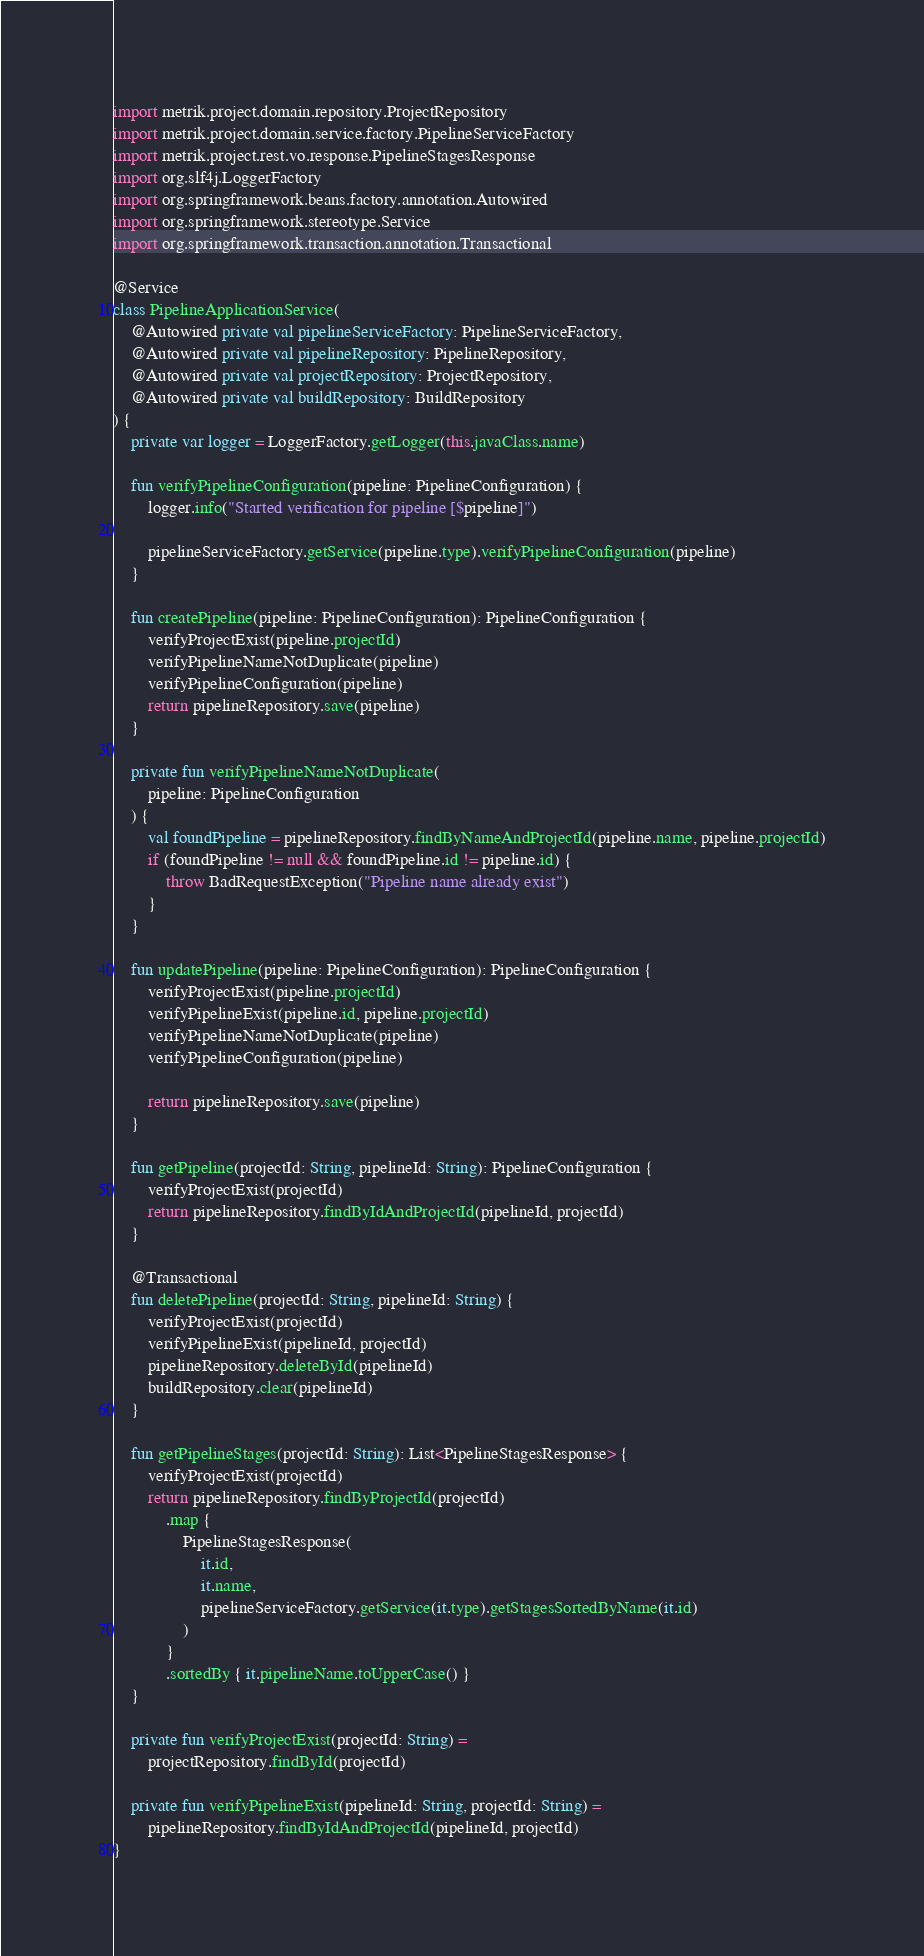Convert code to text. <code><loc_0><loc_0><loc_500><loc_500><_Kotlin_>import metrik.project.domain.repository.ProjectRepository
import metrik.project.domain.service.factory.PipelineServiceFactory
import metrik.project.rest.vo.response.PipelineStagesResponse
import org.slf4j.LoggerFactory
import org.springframework.beans.factory.annotation.Autowired
import org.springframework.stereotype.Service
import org.springframework.transaction.annotation.Transactional

@Service
class PipelineApplicationService(
    @Autowired private val pipelineServiceFactory: PipelineServiceFactory,
    @Autowired private val pipelineRepository: PipelineRepository,
    @Autowired private val projectRepository: ProjectRepository,
    @Autowired private val buildRepository: BuildRepository
) {
    private var logger = LoggerFactory.getLogger(this.javaClass.name)

    fun verifyPipelineConfiguration(pipeline: PipelineConfiguration) {
        logger.info("Started verification for pipeline [$pipeline]")

        pipelineServiceFactory.getService(pipeline.type).verifyPipelineConfiguration(pipeline)
    }

    fun createPipeline(pipeline: PipelineConfiguration): PipelineConfiguration {
        verifyProjectExist(pipeline.projectId)
        verifyPipelineNameNotDuplicate(pipeline)
        verifyPipelineConfiguration(pipeline)
        return pipelineRepository.save(pipeline)
    }

    private fun verifyPipelineNameNotDuplicate(
        pipeline: PipelineConfiguration
    ) {
        val foundPipeline = pipelineRepository.findByNameAndProjectId(pipeline.name, pipeline.projectId)
        if (foundPipeline != null && foundPipeline.id != pipeline.id) {
            throw BadRequestException("Pipeline name already exist")
        }
    }

    fun updatePipeline(pipeline: PipelineConfiguration): PipelineConfiguration {
        verifyProjectExist(pipeline.projectId)
        verifyPipelineExist(pipeline.id, pipeline.projectId)
        verifyPipelineNameNotDuplicate(pipeline)
        verifyPipelineConfiguration(pipeline)

        return pipelineRepository.save(pipeline)
    }

    fun getPipeline(projectId: String, pipelineId: String): PipelineConfiguration {
        verifyProjectExist(projectId)
        return pipelineRepository.findByIdAndProjectId(pipelineId, projectId)
    }

    @Transactional
    fun deletePipeline(projectId: String, pipelineId: String) {
        verifyProjectExist(projectId)
        verifyPipelineExist(pipelineId, projectId)
        pipelineRepository.deleteById(pipelineId)
        buildRepository.clear(pipelineId)
    }

    fun getPipelineStages(projectId: String): List<PipelineStagesResponse> {
        verifyProjectExist(projectId)
        return pipelineRepository.findByProjectId(projectId)
            .map {
                PipelineStagesResponse(
                    it.id,
                    it.name,
                    pipelineServiceFactory.getService(it.type).getStagesSortedByName(it.id)
                )
            }
            .sortedBy { it.pipelineName.toUpperCase() }
    }

    private fun verifyProjectExist(projectId: String) =
        projectRepository.findById(projectId)

    private fun verifyPipelineExist(pipelineId: String, projectId: String) =
        pipelineRepository.findByIdAndProjectId(pipelineId, projectId)
}
</code> 